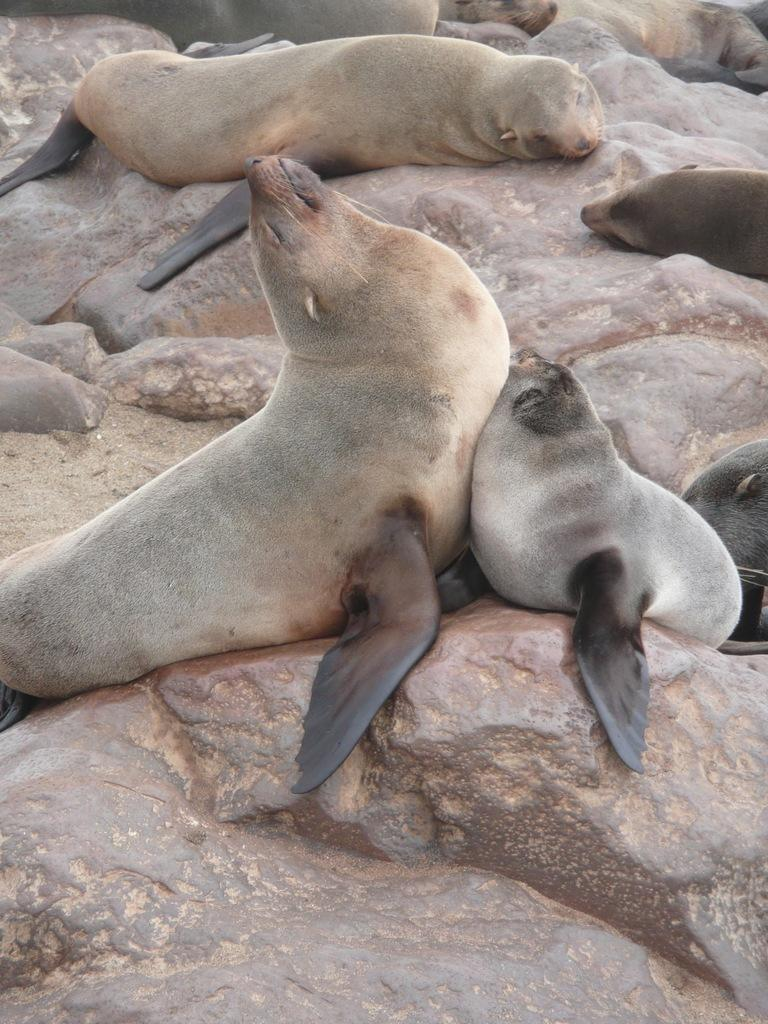What animals are present in the image? There is a group of seals in the image. Where are the seals located? The seals are on rocks. What type of pear is being offered to the beggar in the image? There is no pear or beggar present in the image; it features a group of seals on rocks. 